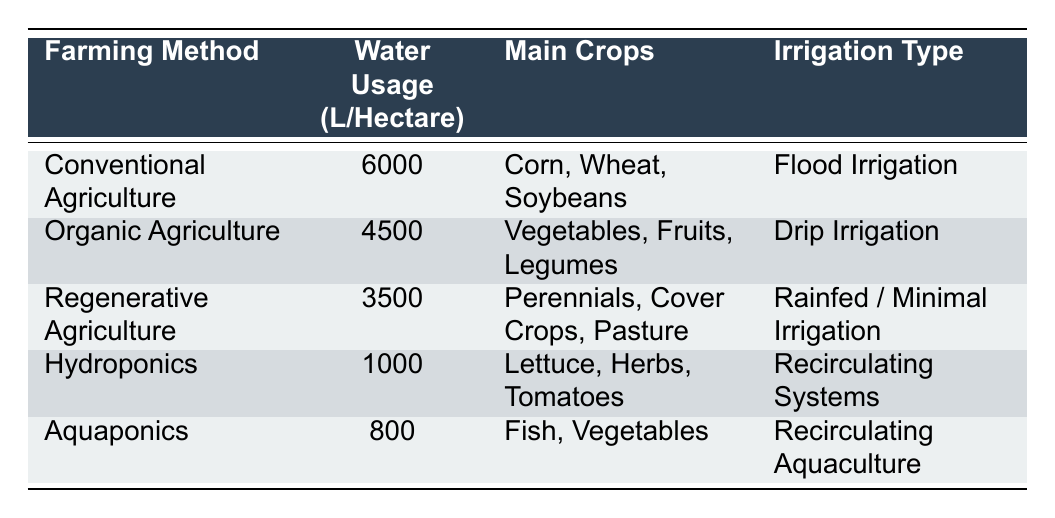What is the water usage per hectare for Hydroponics? According to the table, Hydroponics uses 1000 liters of water per hectare.
Answer: 1000 liters Which farming method has the highest water usage? The table shows that Conventional Agriculture has the highest water usage at 6000 liters per hectare.
Answer: Conventional Agriculture How much less water does Regenerative Agriculture use compared to Conventional Agriculture? Conventional Agriculture uses 6000 liters, while Regenerative Agriculture uses 3500 liters. The difference is 6000 - 3500 = 2500 liters.
Answer: 2500 liters Is Aquaponics more water-efficient than Organic Agriculture? Aquaponics uses 800 liters, while Organic Agriculture uses 4500 liters. Since 800 is less than 4500, Aquaponics is indeed more water-efficient.
Answer: Yes What is the average water usage per hectare of all farming methods listed? To find the average, sum the water usage: 6000 + 4500 + 3500 + 1000 + 800 = 16300 liters. Then, divide by the number of farming methods (5): 16300 / 5 = 3260 liters.
Answer: 3260 liters Which irrigation type uses the least amount of water based on the data? Based on the table, Aquaponics uses the least amount of water at 800 liters per hectare, and it employs Recirculating Aquaculture as its irrigation type.
Answer: Aquaponics Is there any farming method that uses more than 5000 liters per hectare? The table indicates that only Conventional Agriculture exceeds 5000 liters, as it uses 6000 liters per hectare, confirming the statement as true.
Answer: Yes What percentage less water does Organic Agriculture use compared to Conventional Agriculture? The difference is 6000 - 4500 = 1500 liters. To find the percentage of savings: (1500 / 6000) * 100 = 25%. Organic Agriculture uses 25% less water.
Answer: 25% What are the main crops for the farming method that uses 800 liters of water? According to the table, Aquaponics, which uses 800 liters, grows Fish and Vegetables.
Answer: Fish, Vegetables 